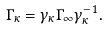<formula> <loc_0><loc_0><loc_500><loc_500>\Gamma _ { \kappa } = \gamma _ { \kappa } \Gamma _ { \infty } \gamma _ { \kappa } ^ { - 1 } .</formula> 